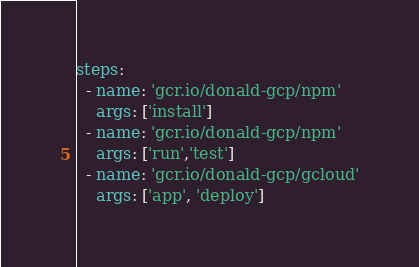Convert code to text. <code><loc_0><loc_0><loc_500><loc_500><_YAML_>steps:
  - name: 'gcr.io/donald-gcp/npm'
    args: ['install']
  - name: 'gcr.io/donald-gcp/npm'
    args: ['run','test']
  - name: 'gcr.io/donald-gcp/gcloud'
    args: ['app', 'deploy']</code> 